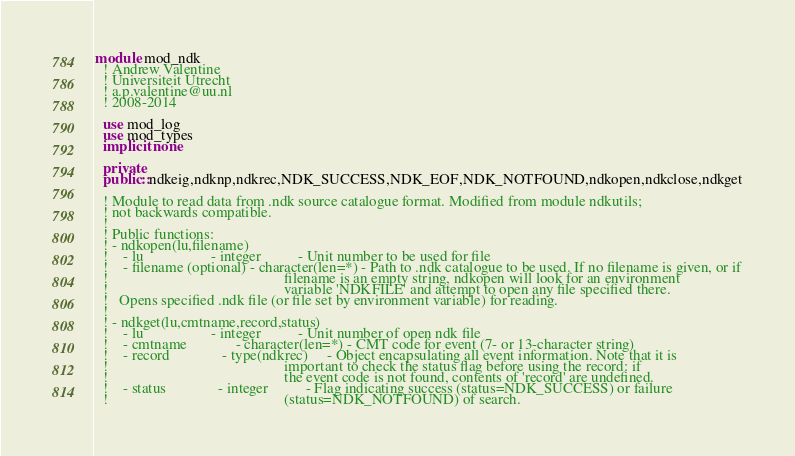<code> <loc_0><loc_0><loc_500><loc_500><_FORTRAN_>module mod_ndk
  ! Andrew Valentine
  ! Universiteit Utrecht
  ! a.p.valentine@uu.nl
  ! 2008-2014

  use mod_log
  use mod_types
  implicit none

  private
  public::ndkeig,ndknp,ndkrec,NDK_SUCCESS,NDK_EOF,NDK_NOTFOUND,ndkopen,ndkclose,ndkget

  ! Module to read data from .ndk source catalogue format. Modified from module ndkutils;
  ! not backwards compatible.
  !
  ! Public functions:
  ! - ndkopen(lu,filename)
  !    - lu                  - integer          - Unit number to be used for file
  !    - filename (optional) - character(len=*) - Path to .ndk catalogue to be used. If no filename is given, or if
  !                                               filename is an empty string, ndkopen will look for an environment
  !                                               variable 'NDKFILE' and attempt to open any file specified there.
  !   Opens specified .ndk file (or file set by environment variable) for reading.
  !
  ! - ndkget(lu,cmtname,record,status)
  !    - lu                  - integer          - Unit number of open ndk file
  !    - cmtname             - character(len=*) - CMT code for event (7- or 13-character string)
  !    - record              - type(ndkrec)     - Object encapsulating all event information. Note that it is
  !                                               important to check the status flag before using the record: if
  !                                               the event code is not found, contents of 'record' are undefined.
  !    - status              - integer          - Flag indicating success (status=NDK_SUCCESS) or failure
  !                                               (status=NDK_NOTFOUND) of search.</code> 